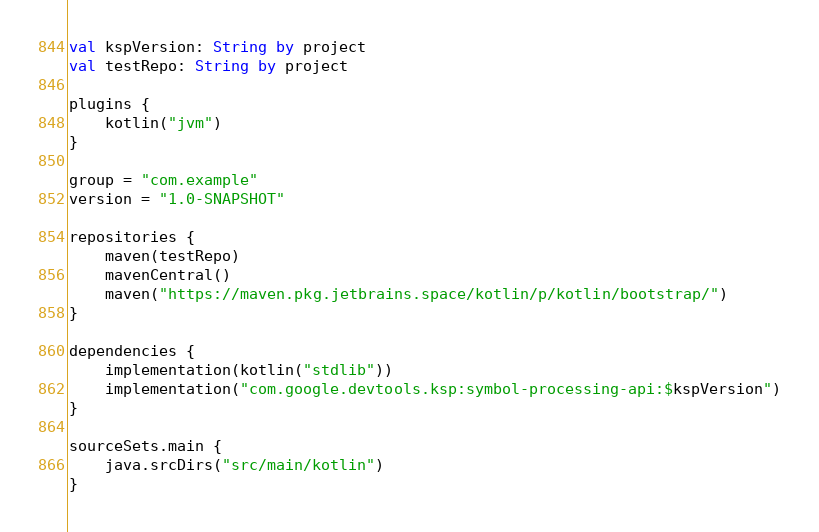Convert code to text. <code><loc_0><loc_0><loc_500><loc_500><_Kotlin_>val kspVersion: String by project
val testRepo: String by project

plugins {
    kotlin("jvm")
}

group = "com.example"
version = "1.0-SNAPSHOT"

repositories {
    maven(testRepo)
    mavenCentral()
    maven("https://maven.pkg.jetbrains.space/kotlin/p/kotlin/bootstrap/")
}

dependencies {
    implementation(kotlin("stdlib"))
    implementation("com.google.devtools.ksp:symbol-processing-api:$kspVersion")
}

sourceSets.main {
    java.srcDirs("src/main/kotlin")
}
</code> 